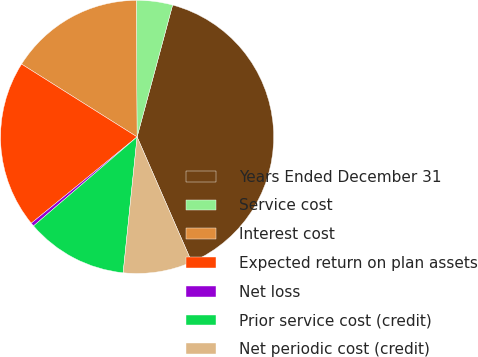Convert chart. <chart><loc_0><loc_0><loc_500><loc_500><pie_chart><fcel>Years Ended December 31<fcel>Service cost<fcel>Interest cost<fcel>Expected return on plan assets<fcel>Net loss<fcel>Prior service cost (credit)<fcel>Net periodic cost (credit)<nl><fcel>39.26%<fcel>4.29%<fcel>15.95%<fcel>19.84%<fcel>0.41%<fcel>12.07%<fcel>8.18%<nl></chart> 